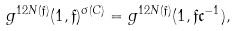<formula> <loc_0><loc_0><loc_500><loc_500>g ^ { 1 2 N ( \mathfrak { f } ) } ( 1 , \mathfrak { f } ) ^ { \sigma ( C ) } = g ^ { 1 2 N ( \mathfrak { f } ) } ( 1 , \mathfrak { f } \mathfrak { c } ^ { - 1 } ) ,</formula> 